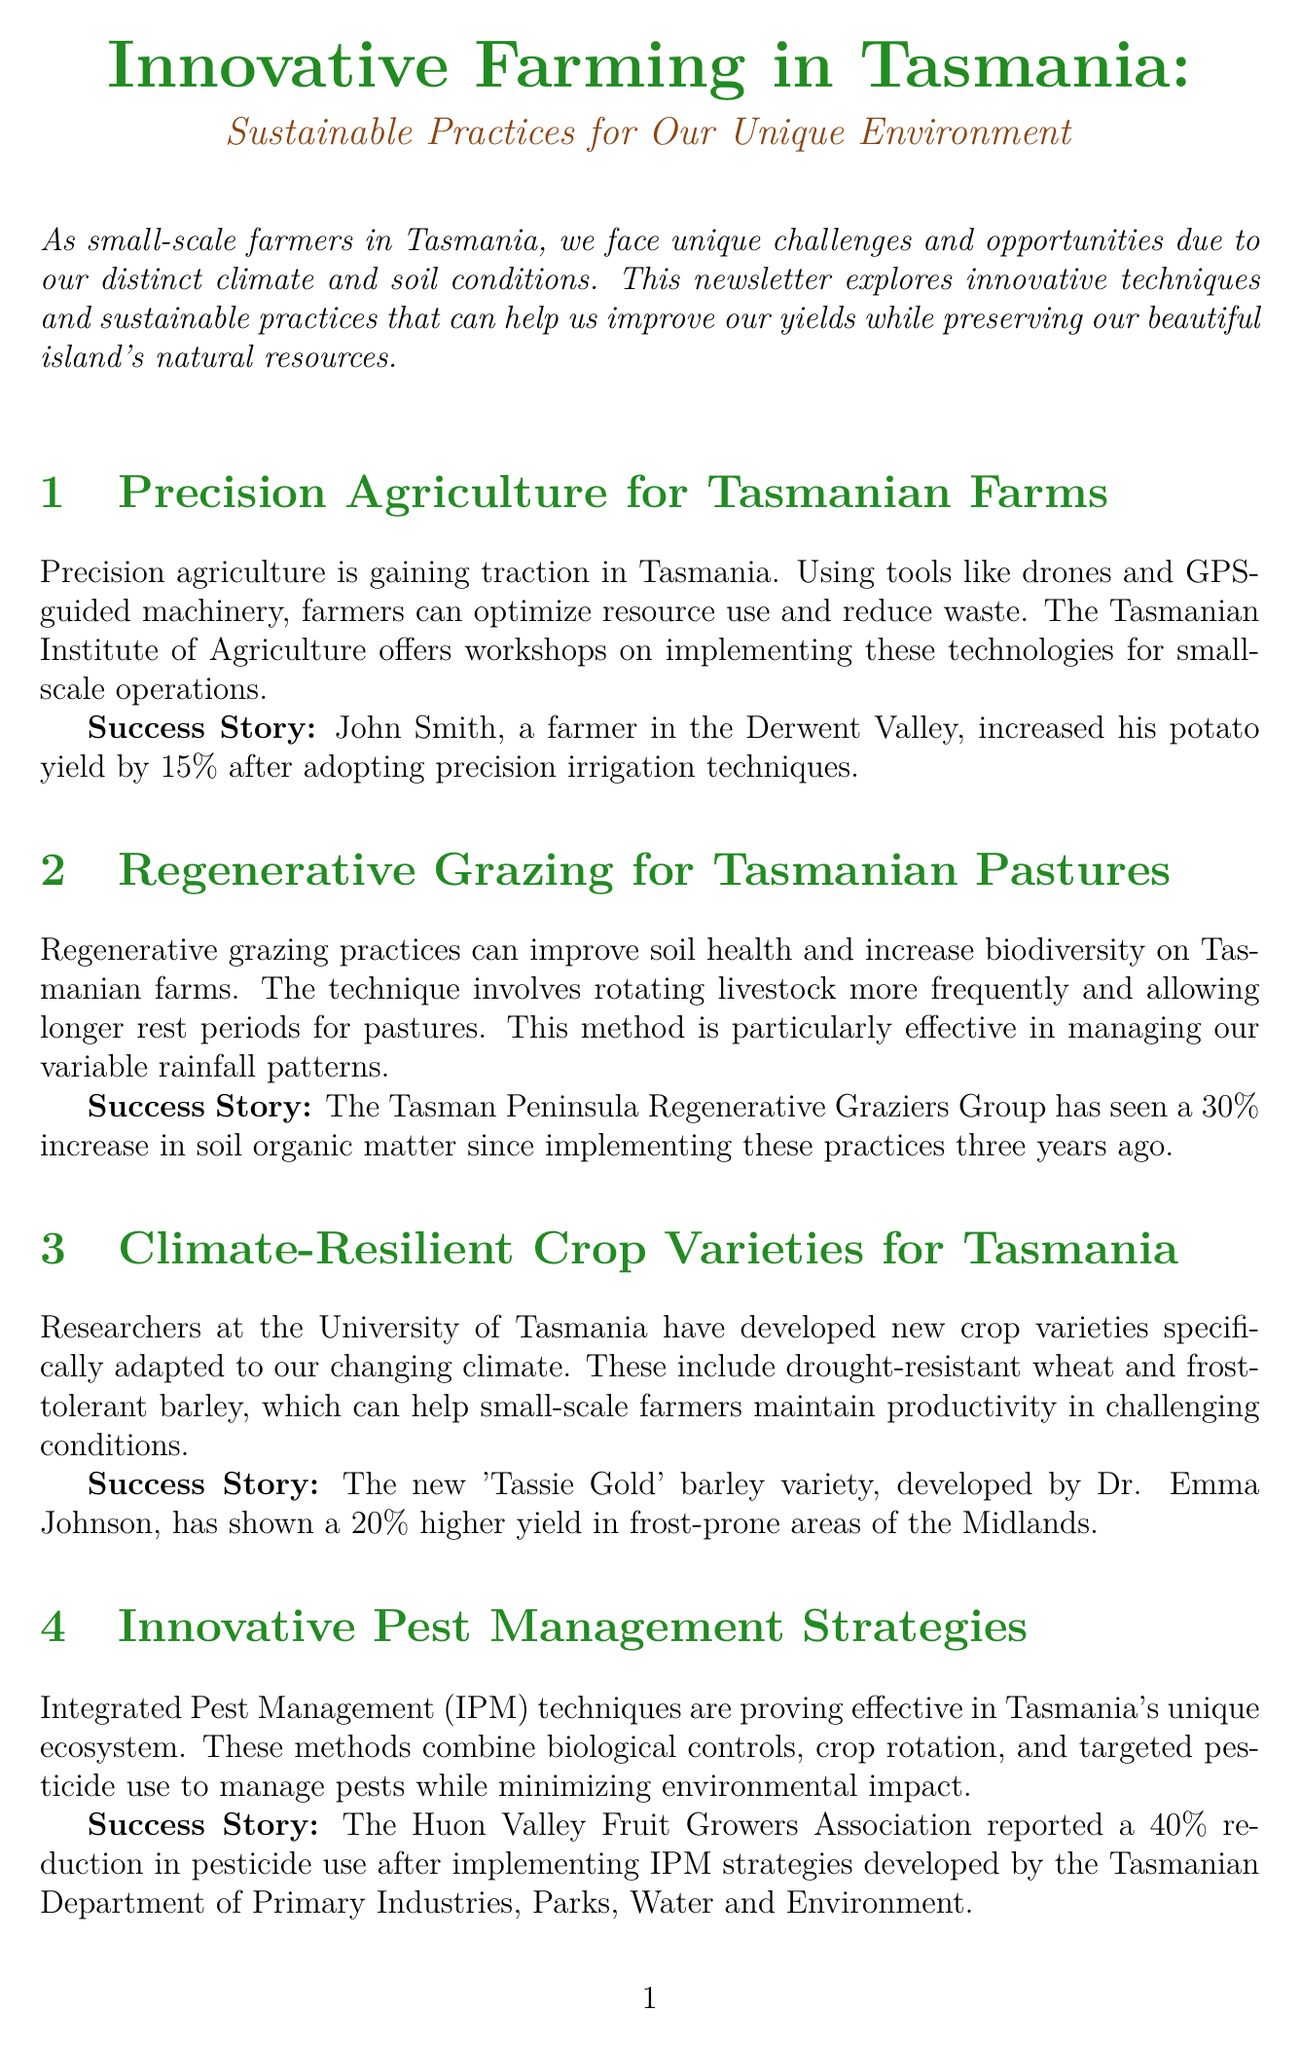What is the title of the newsletter? The title of the newsletter is mentioned at the beginning as "Innovative Farming in Tasmania: Sustainable Practices for Our Unique Environment."
Answer: Innovative Farming in Tasmania: Sustainable Practices for Our Unique Environment What technique did John Smith adopt? John Smith, a farmer in the Derwent Valley, adopted precision irrigation techniques to improve his potato yield.
Answer: Precision irrigation By what percentage did John Smith increase his potato yield? The document states that John Smith increased his potato yield by 15% after adopting precision irrigation techniques.
Answer: 15% What local initiative offers grants for sustainable practices? The document mentions "The Tamar Valley Sustainable Farming Network" as the local initiative that offers grants to small-scale farmers.
Answer: The Tamar Valley Sustainable Farming Network How much has soil organic matter increased by the Tasman Peninsula Regenerative Graziers Group? The document reports a 30% increase in soil organic matter since the group implemented regenerative grazing practices three years ago.
Answer: 30% What is one of the recommended sustainability practices? One of the practices listed is "Installing solar panels to power farm operations."
Answer: Installing solar panels What crop variety has shown a 20% higher yield in frost-prone areas? The newsletter provides an example of "Tassie Gold" barley variety developed by Dr. Emma Johnson, which has shown this yield increase.
Answer: Tassie Gold What percentage reduction in pesticide use was reported by the Huon Valley Fruit Growers Association? The document indicates that there was a 40% reduction in pesticide use after implementing Integrated Pest Management strategies.
Answer: 40% What organization offers workshops on precision agriculture? The Tasmanian Institute of Agriculture is mentioned as offering workshops on implementing precision agriculture technologies for small-scale farms.
Answer: Tasmanian Institute of Agriculture 